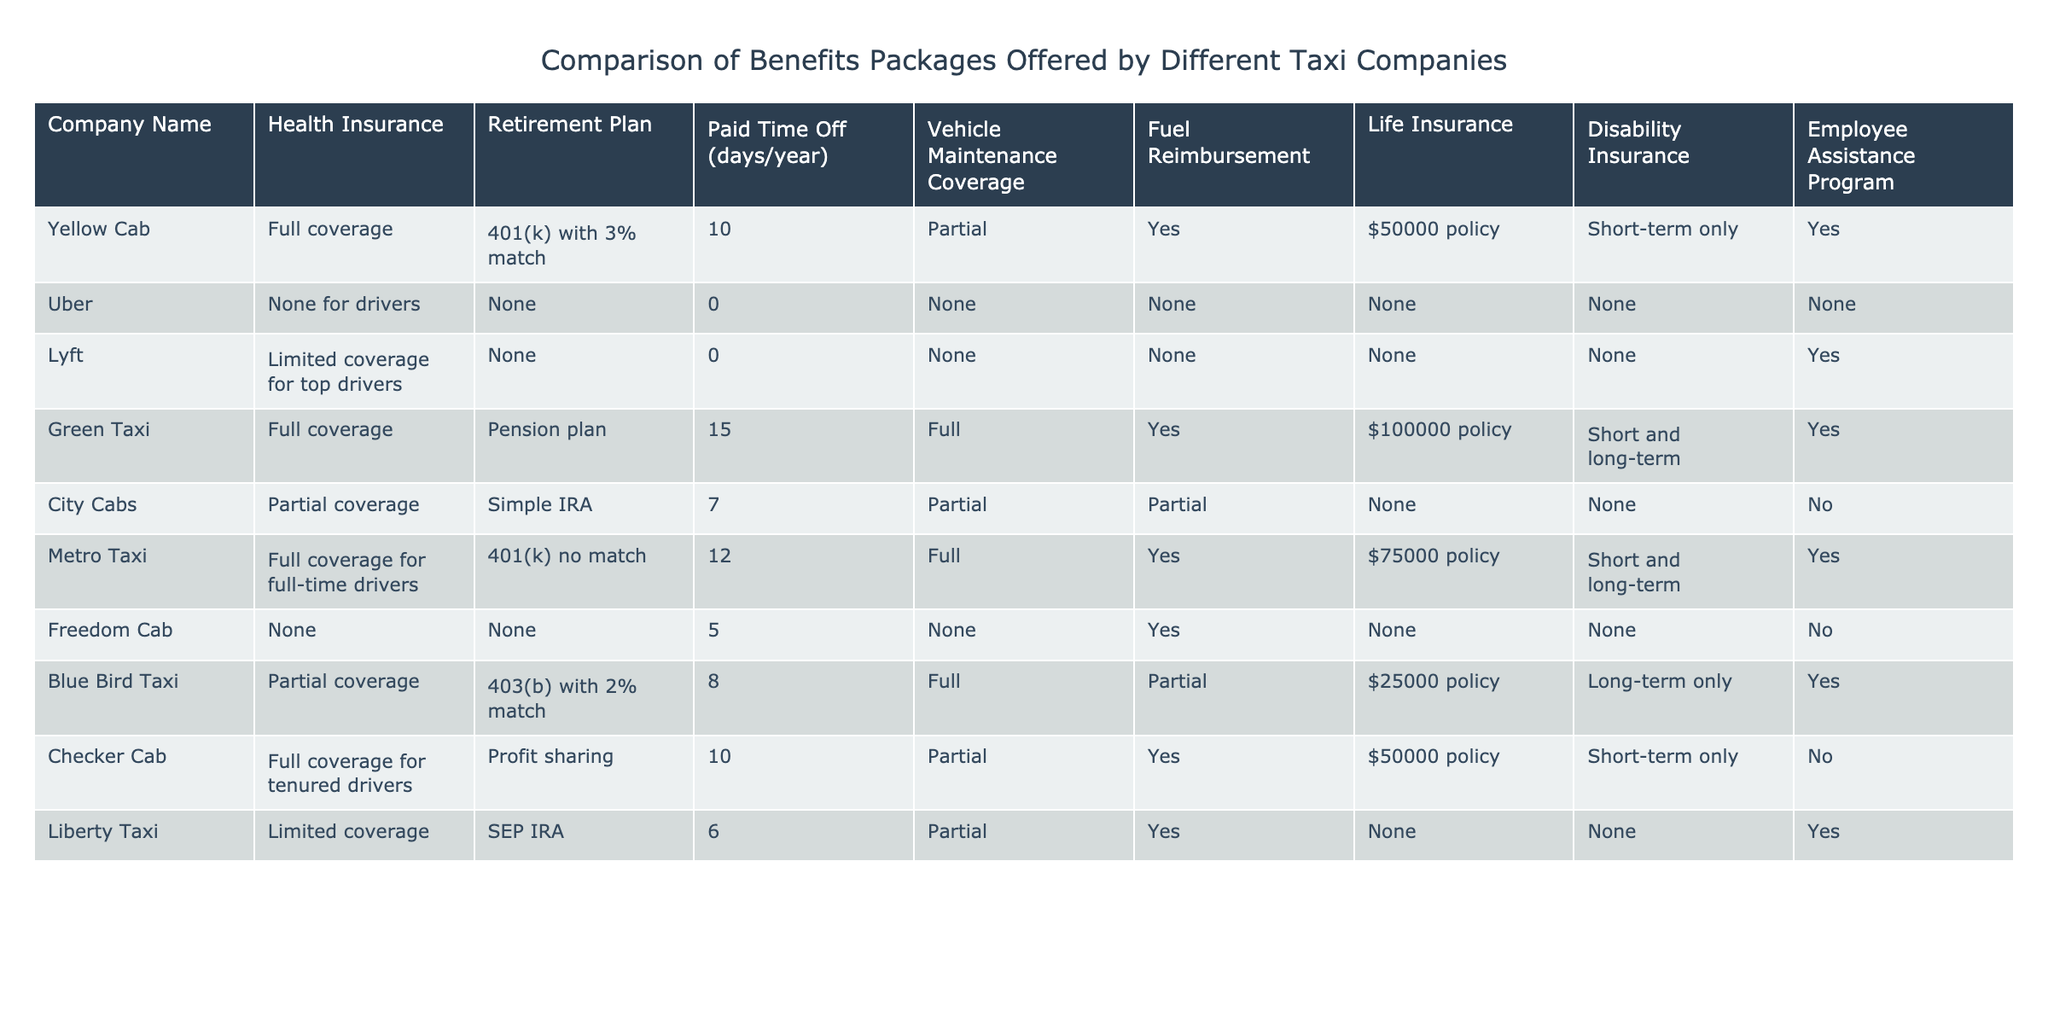What type of health insurance does Uber offer its drivers? Uber offers no health insurance for its drivers, as indicated in the table.
Answer: None How many paid time off days does Green Taxi provide? According to the table, Green Taxi offers 15 paid time off days per year.
Answer: 15 days Does Yellow Cab provide life insurance? Yes, Yellow Cab offers a life insurance policy worth $50,000, as shown in the table.
Answer: Yes What companies offer full vehicle maintenance coverage? Green Taxi and Metro Taxi provide full vehicle maintenance coverage, as stated in their respective entries in the table.
Answer: Green Taxi and Metro Taxi Which company has the best retirement plan? Green Taxi offers a pension plan, which is typically more favorable compared to the 401(k) with or without match plans from other companies. Therefore, it can be considered the best retirement plan.
Answer: Green Taxi What is the maximum amount of paid time off available among all companies? After reviewing the paid time off offered by each company, Green Taxi with 15 days has the maximum. Therefore, the maximum amount is 15 days.
Answer: 15 days Is there a company that offers both short-term and long-term disability insurance? Yes, both Metro Taxi and Green Taxi offer short and long-term disability insurance.
Answer: Yes How many companies provide limited health insurance? There are three companies—Lyft, Liberty Taxi, and Yellow Cab—that provide limited health insurance.
Answer: Three companies Which taxi company has the lowest life insurance coverage? Blue Bird Taxi has the lowest life insurance coverage at $25,000 according to the table.
Answer: $25,000 If we compare the paid time off between Checker Cab and City Cabs, which one has more days? Checker Cab has 10 days of paid time off while City Cabs only has 7 days, so Checker Cab offers more days.
Answer: Checker Cab 